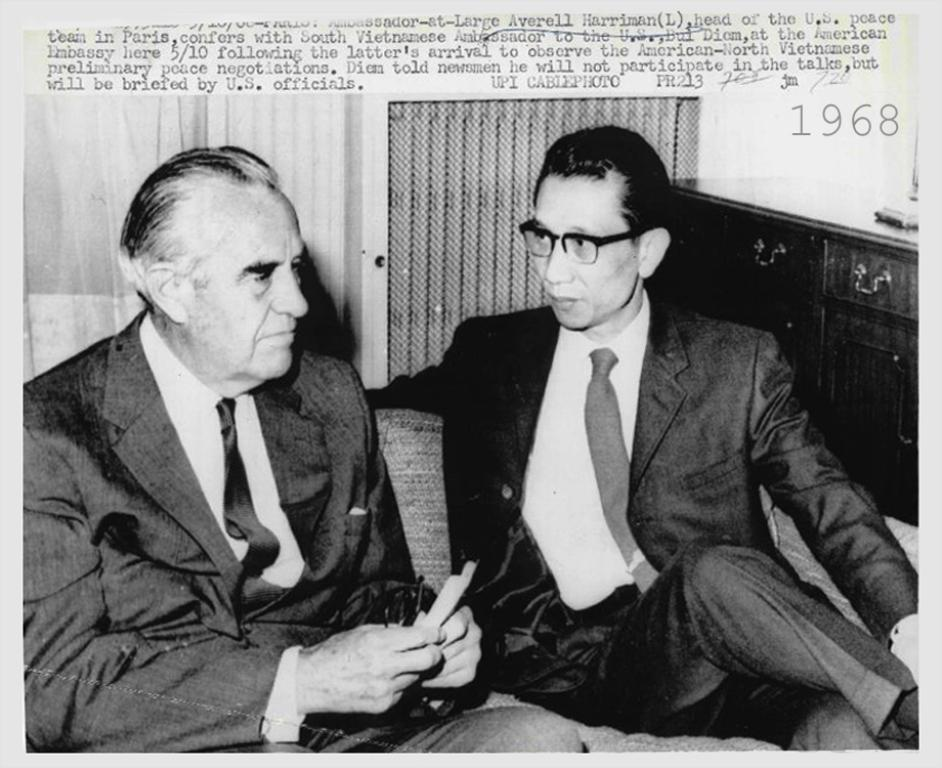What is the main subject of the image? There is a poster in the image. What is depicted on the poster? The poster contains two men sitting on a sofa. What can be seen behind the two men on the poster? There are cupboards visible behind the two men. What information is visible at the top of the image? There is some information visible at the top of the image. How does the health of the two men on the poster compare to each other in the image? There is no information about the health of the two men on the poster in the image. What type of competition is being depicted on the poster? There is no competition depicted on the poster; it simply shows two men sitting on a sofa. 